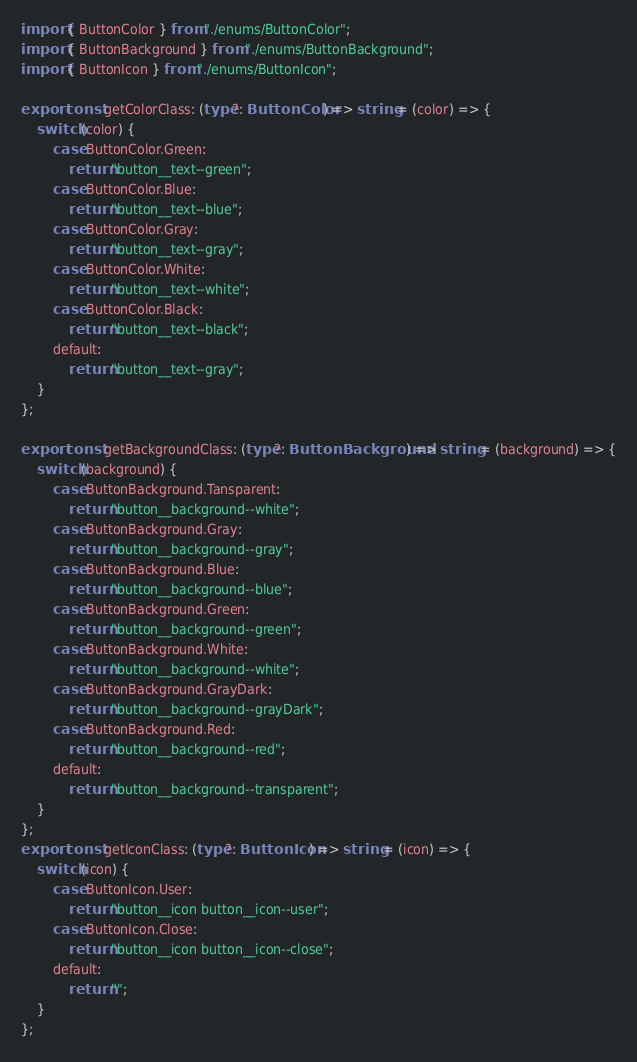<code> <loc_0><loc_0><loc_500><loc_500><_TypeScript_>import { ButtonColor } from "./enums/ButtonColor";
import { ButtonBackground } from "./enums/ButtonBackground";
import { ButtonIcon } from "./enums/ButtonIcon";

export const getColorClass: (type?: ButtonColor) => string = (color) => {
	switch (color) {
		case ButtonColor.Green:
			return "button__text--green";
		case ButtonColor.Blue:
			return "button__text--blue";
		case ButtonColor.Gray:
			return "button__text--gray";
		case ButtonColor.White:
			return "button__text--white";
		case ButtonColor.Black:
			return "button__text--black";
		default:
			return "button__text--gray";
	}
};

export const getBackgroundClass: (type?: ButtonBackground) => string = (background) => {
	switch (background) {
		case ButtonBackground.Tansparent:
			return "button__background--white";
		case ButtonBackground.Gray:
			return "button__background--gray";
		case ButtonBackground.Blue:
			return "button__background--blue";
		case ButtonBackground.Green:
			return "button__background--green";
		case ButtonBackground.White:
			return "button__background--white";
		case ButtonBackground.GrayDark:
			return "button__background--grayDark";
		case ButtonBackground.Red:
			return "button__background--red";
		default:
			return "button__background--transparent";
	}
};
export const getIconClass: (type?: ButtonIcon) => string = (icon) => {
	switch (icon) {
		case ButtonIcon.User:
			return "button__icon button__icon--user";
		case ButtonIcon.Close:
			return "button__icon button__icon--close";
		default:
			return "";
	}
};
</code> 